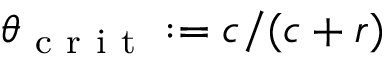Convert formula to latex. <formula><loc_0><loc_0><loc_500><loc_500>\theta _ { c r i t } \colon = c / ( c + r )</formula> 